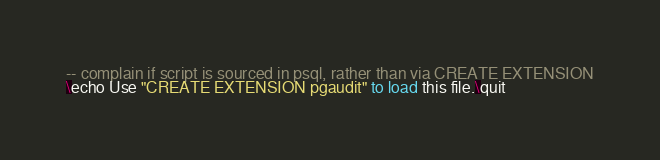<code> <loc_0><loc_0><loc_500><loc_500><_SQL_>-- complain if script is sourced in psql, rather than via CREATE EXTENSION
\echo Use "CREATE EXTENSION pgaudit" to load this file.\quit
</code> 